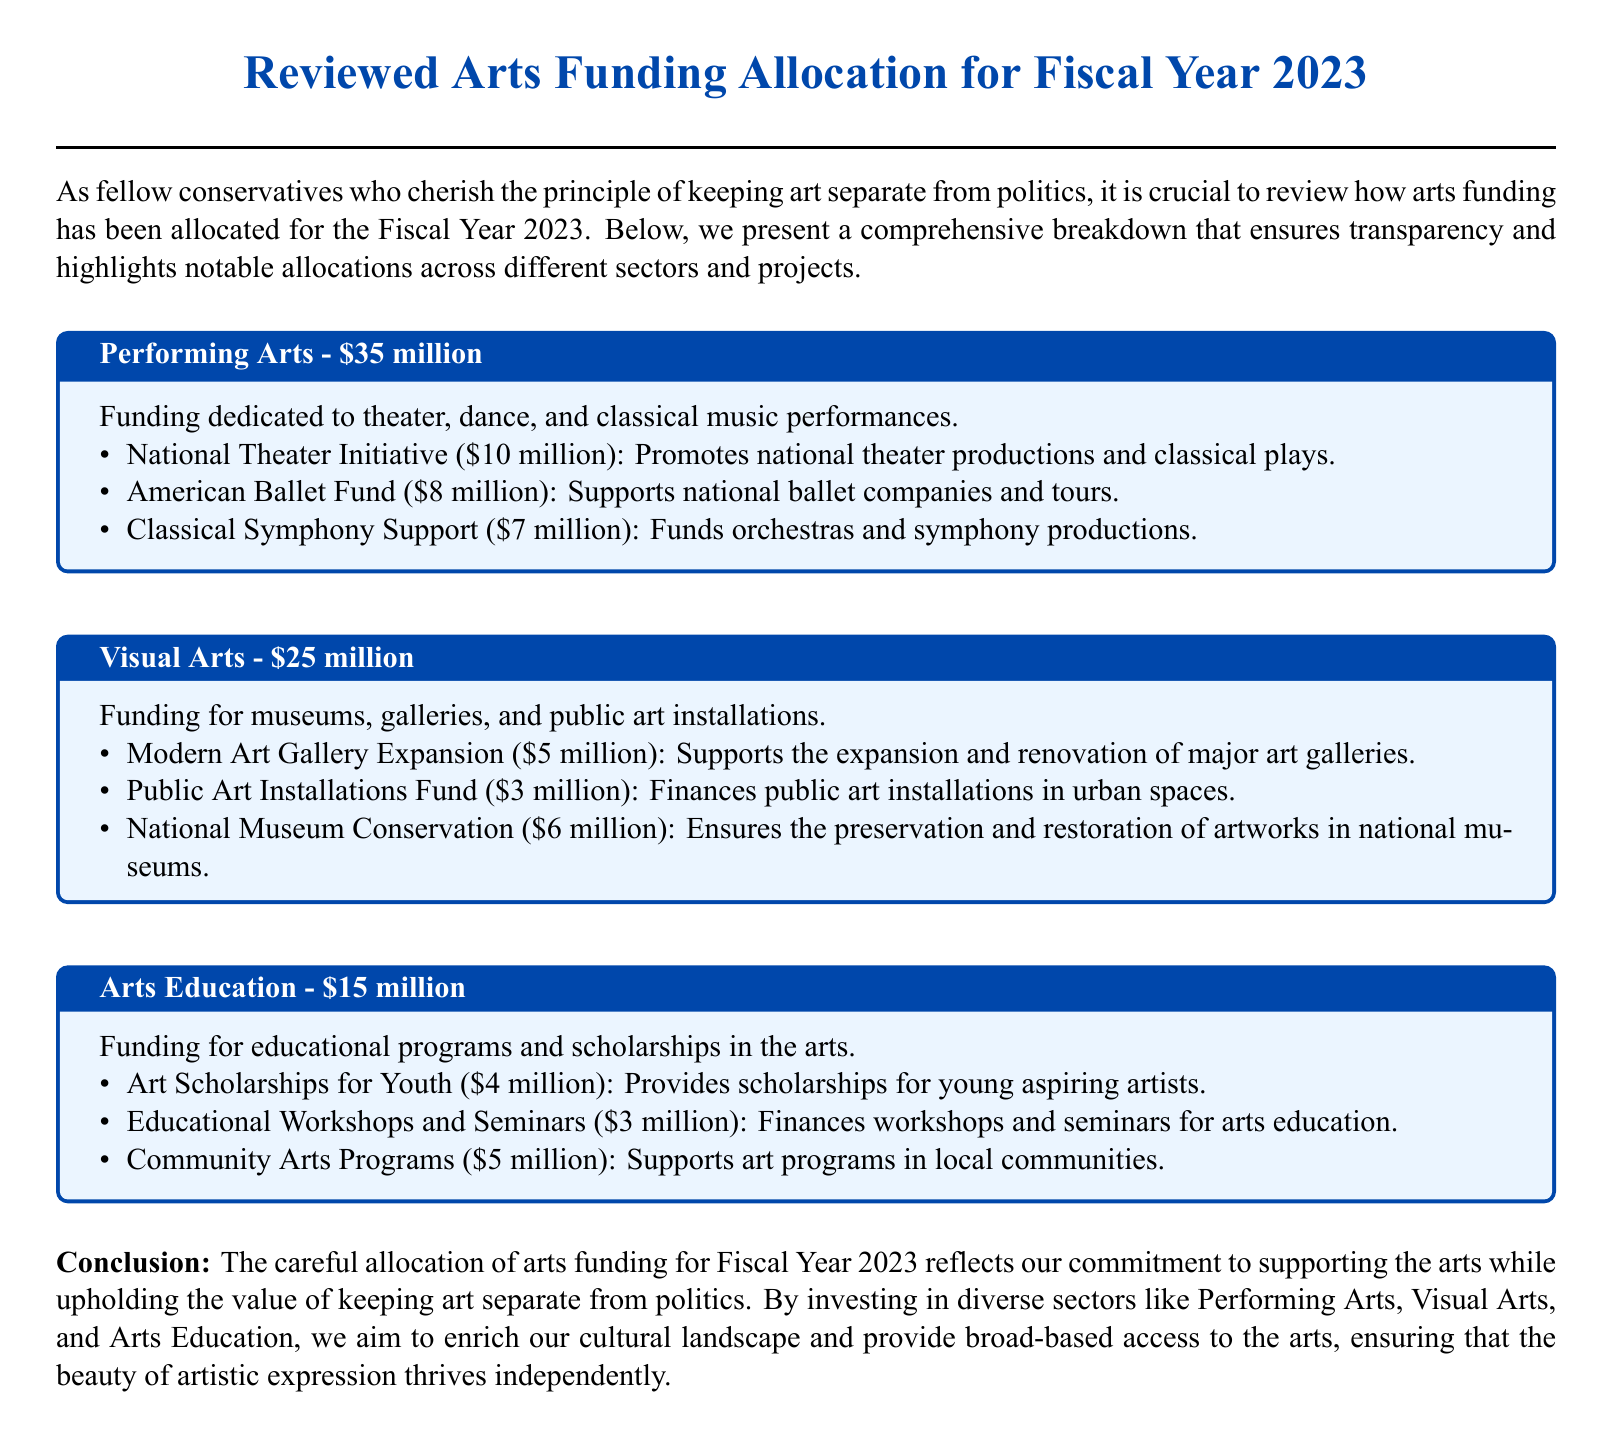What is the total funding for Performing Arts? The total funding for Performing Arts is listed in the document as $35 million.
Answer: $35 million How much funding is allocated for Visual Arts? The funding for Visual Arts is stated as part of the breakdown, which is $25 million.
Answer: $25 million What project receives the highest funding in the Performing Arts section? The project with the highest funding is the National Theater Initiative, which receives $10 million.
Answer: National Theater Initiative What is the funding amount for Arts Education? The document specifies that the funding amount for Arts Education is $15 million.
Answer: $15 million What percentage of the total funding is dedicated to Visual Arts? The total funding for all sectors is $75 million. Visual Arts receives $25 million, which is one-third, or about 33.33%.
Answer: 33.33% How many projects are listed under the Arts Education funding? There are three distinct projects outlined under the Arts Education funding section.
Answer: Three Which program supports young aspiring artists? The Art Scholarships for Youth program is specifically mentioned as supporting young aspiring artists.
Answer: Art Scholarships for Youth What type of funding does the National Museum Conservation provide? The funding type provided by the National Museum Conservation is for preservation and restoration of artworks.
Answer: Preservation and restoration 